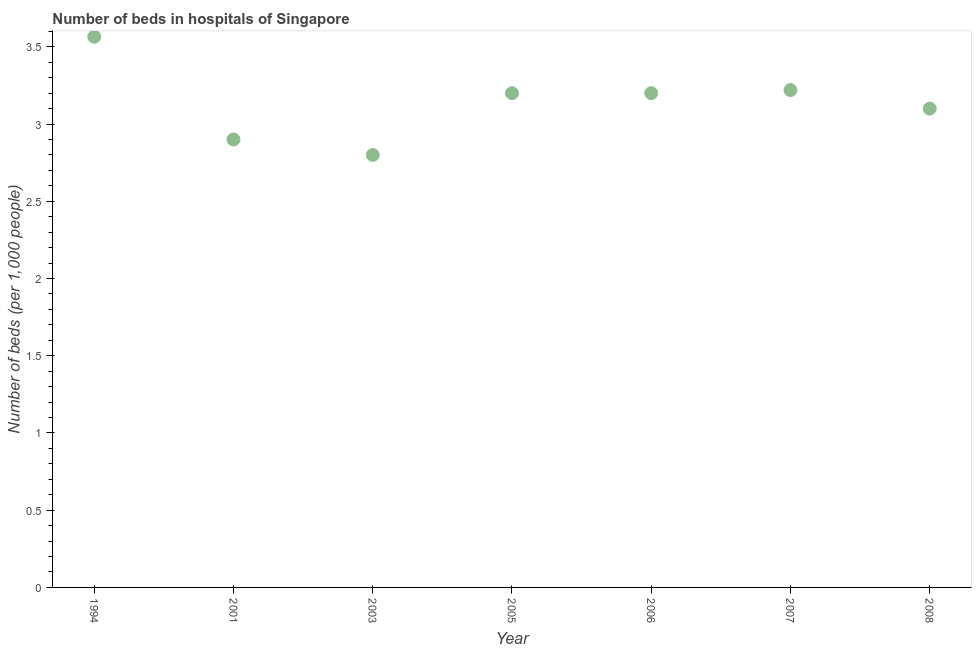What is the number of hospital beds in 2007?
Ensure brevity in your answer.  3.22. Across all years, what is the maximum number of hospital beds?
Offer a terse response. 3.57. What is the sum of the number of hospital beds?
Provide a succinct answer. 21.99. What is the difference between the number of hospital beds in 2006 and 2007?
Give a very brief answer. -0.02. What is the average number of hospital beds per year?
Offer a terse response. 3.14. What is the ratio of the number of hospital beds in 2003 to that in 2005?
Make the answer very short. 0.87. Is the difference between the number of hospital beds in 1994 and 2005 greater than the difference between any two years?
Keep it short and to the point. No. What is the difference between the highest and the second highest number of hospital beds?
Offer a terse response. 0.35. Is the sum of the number of hospital beds in 2006 and 2007 greater than the maximum number of hospital beds across all years?
Your answer should be very brief. Yes. What is the difference between the highest and the lowest number of hospital beds?
Your answer should be compact. 0.77. Does the number of hospital beds monotonically increase over the years?
Offer a very short reply. No. How many dotlines are there?
Your answer should be very brief. 1. How many years are there in the graph?
Ensure brevity in your answer.  7. Are the values on the major ticks of Y-axis written in scientific E-notation?
Make the answer very short. No. What is the title of the graph?
Offer a terse response. Number of beds in hospitals of Singapore. What is the label or title of the Y-axis?
Give a very brief answer. Number of beds (per 1,0 people). What is the Number of beds (per 1,000 people) in 1994?
Your answer should be very brief. 3.57. What is the Number of beds (per 1,000 people) in 2001?
Ensure brevity in your answer.  2.9. What is the Number of beds (per 1,000 people) in 2003?
Give a very brief answer. 2.8. What is the Number of beds (per 1,000 people) in 2006?
Provide a short and direct response. 3.2. What is the Number of beds (per 1,000 people) in 2007?
Make the answer very short. 3.22. What is the Number of beds (per 1,000 people) in 2008?
Your answer should be compact. 3.1. What is the difference between the Number of beds (per 1,000 people) in 1994 and 2001?
Ensure brevity in your answer.  0.67. What is the difference between the Number of beds (per 1,000 people) in 1994 and 2003?
Offer a very short reply. 0.77. What is the difference between the Number of beds (per 1,000 people) in 1994 and 2005?
Ensure brevity in your answer.  0.37. What is the difference between the Number of beds (per 1,000 people) in 1994 and 2006?
Your response must be concise. 0.37. What is the difference between the Number of beds (per 1,000 people) in 1994 and 2007?
Provide a short and direct response. 0.35. What is the difference between the Number of beds (per 1,000 people) in 1994 and 2008?
Keep it short and to the point. 0.47. What is the difference between the Number of beds (per 1,000 people) in 2001 and 2003?
Ensure brevity in your answer.  0.1. What is the difference between the Number of beds (per 1,000 people) in 2001 and 2005?
Your response must be concise. -0.3. What is the difference between the Number of beds (per 1,000 people) in 2001 and 2007?
Your answer should be compact. -0.32. What is the difference between the Number of beds (per 1,000 people) in 2001 and 2008?
Make the answer very short. -0.2. What is the difference between the Number of beds (per 1,000 people) in 2003 and 2005?
Ensure brevity in your answer.  -0.4. What is the difference between the Number of beds (per 1,000 people) in 2003 and 2007?
Keep it short and to the point. -0.42. What is the difference between the Number of beds (per 1,000 people) in 2005 and 2007?
Your response must be concise. -0.02. What is the difference between the Number of beds (per 1,000 people) in 2005 and 2008?
Your response must be concise. 0.1. What is the difference between the Number of beds (per 1,000 people) in 2006 and 2007?
Your response must be concise. -0.02. What is the difference between the Number of beds (per 1,000 people) in 2006 and 2008?
Provide a short and direct response. 0.1. What is the difference between the Number of beds (per 1,000 people) in 2007 and 2008?
Your response must be concise. 0.12. What is the ratio of the Number of beds (per 1,000 people) in 1994 to that in 2001?
Your answer should be compact. 1.23. What is the ratio of the Number of beds (per 1,000 people) in 1994 to that in 2003?
Your answer should be compact. 1.27. What is the ratio of the Number of beds (per 1,000 people) in 1994 to that in 2005?
Offer a terse response. 1.11. What is the ratio of the Number of beds (per 1,000 people) in 1994 to that in 2006?
Offer a very short reply. 1.11. What is the ratio of the Number of beds (per 1,000 people) in 1994 to that in 2007?
Offer a very short reply. 1.11. What is the ratio of the Number of beds (per 1,000 people) in 1994 to that in 2008?
Offer a very short reply. 1.15. What is the ratio of the Number of beds (per 1,000 people) in 2001 to that in 2003?
Your response must be concise. 1.04. What is the ratio of the Number of beds (per 1,000 people) in 2001 to that in 2005?
Your response must be concise. 0.91. What is the ratio of the Number of beds (per 1,000 people) in 2001 to that in 2006?
Offer a terse response. 0.91. What is the ratio of the Number of beds (per 1,000 people) in 2001 to that in 2007?
Your answer should be very brief. 0.9. What is the ratio of the Number of beds (per 1,000 people) in 2001 to that in 2008?
Keep it short and to the point. 0.94. What is the ratio of the Number of beds (per 1,000 people) in 2003 to that in 2007?
Provide a short and direct response. 0.87. What is the ratio of the Number of beds (per 1,000 people) in 2003 to that in 2008?
Offer a terse response. 0.9. What is the ratio of the Number of beds (per 1,000 people) in 2005 to that in 2007?
Offer a terse response. 0.99. What is the ratio of the Number of beds (per 1,000 people) in 2005 to that in 2008?
Offer a very short reply. 1.03. What is the ratio of the Number of beds (per 1,000 people) in 2006 to that in 2007?
Your answer should be very brief. 0.99. What is the ratio of the Number of beds (per 1,000 people) in 2006 to that in 2008?
Offer a very short reply. 1.03. What is the ratio of the Number of beds (per 1,000 people) in 2007 to that in 2008?
Provide a short and direct response. 1.04. 